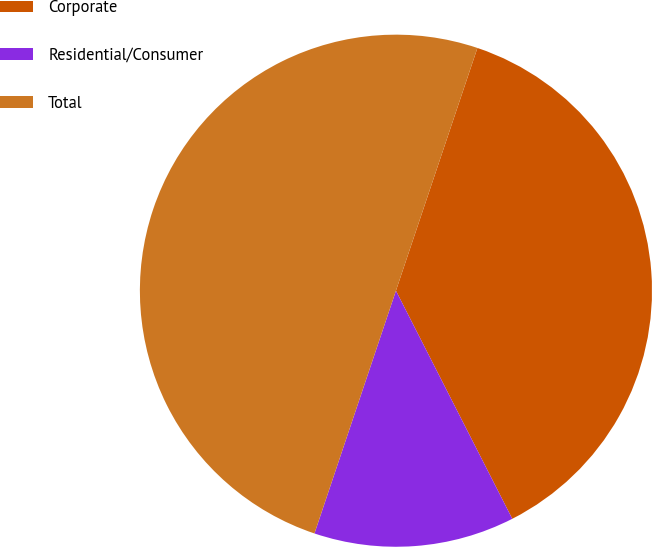<chart> <loc_0><loc_0><loc_500><loc_500><pie_chart><fcel>Corporate<fcel>Residential/Consumer<fcel>Total<nl><fcel>37.34%<fcel>12.66%<fcel>50.0%<nl></chart> 